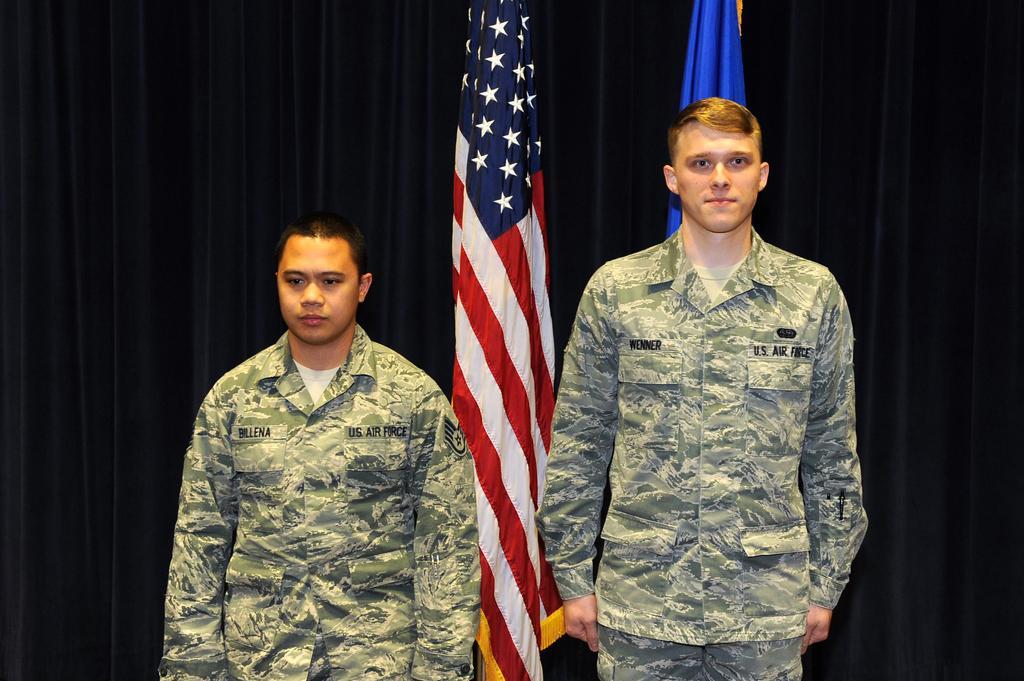Can you describe this image briefly? In this image we can see two persons. Behind the persons there are two flags. In the background of the image there is a black curtain. 